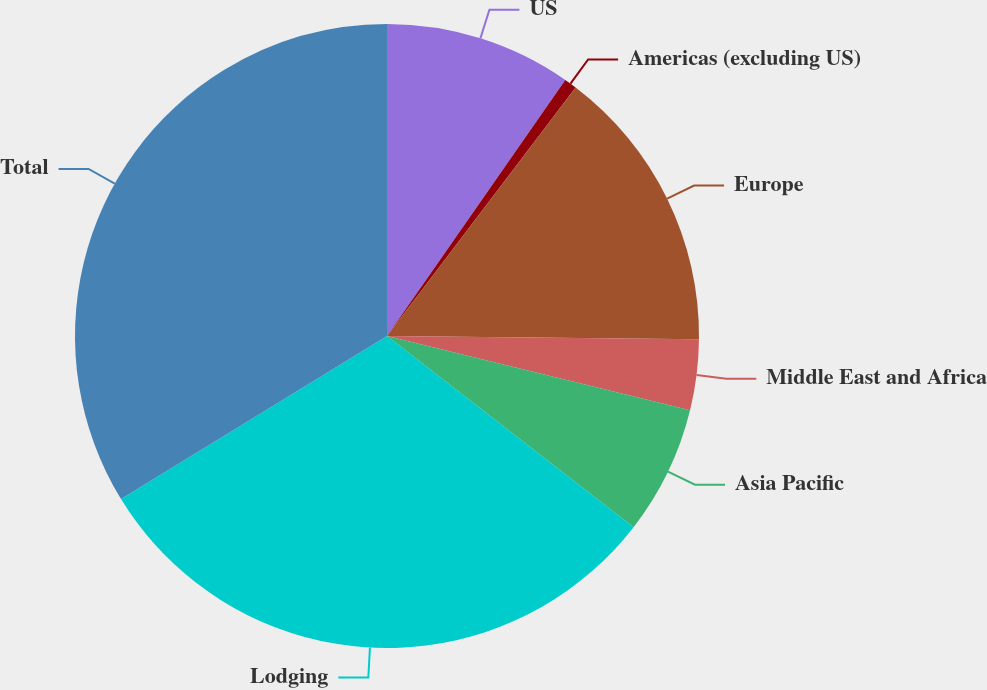Convert chart to OTSL. <chart><loc_0><loc_0><loc_500><loc_500><pie_chart><fcel>US<fcel>Americas (excluding US)<fcel>Europe<fcel>Middle East and Africa<fcel>Asia Pacific<fcel>Lodging<fcel>Total<nl><fcel>9.68%<fcel>0.65%<fcel>14.83%<fcel>3.66%<fcel>6.67%<fcel>30.75%<fcel>33.75%<nl></chart> 